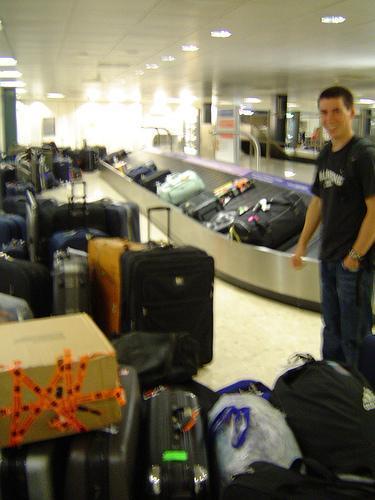How many people are visible?
Give a very brief answer. 1. 